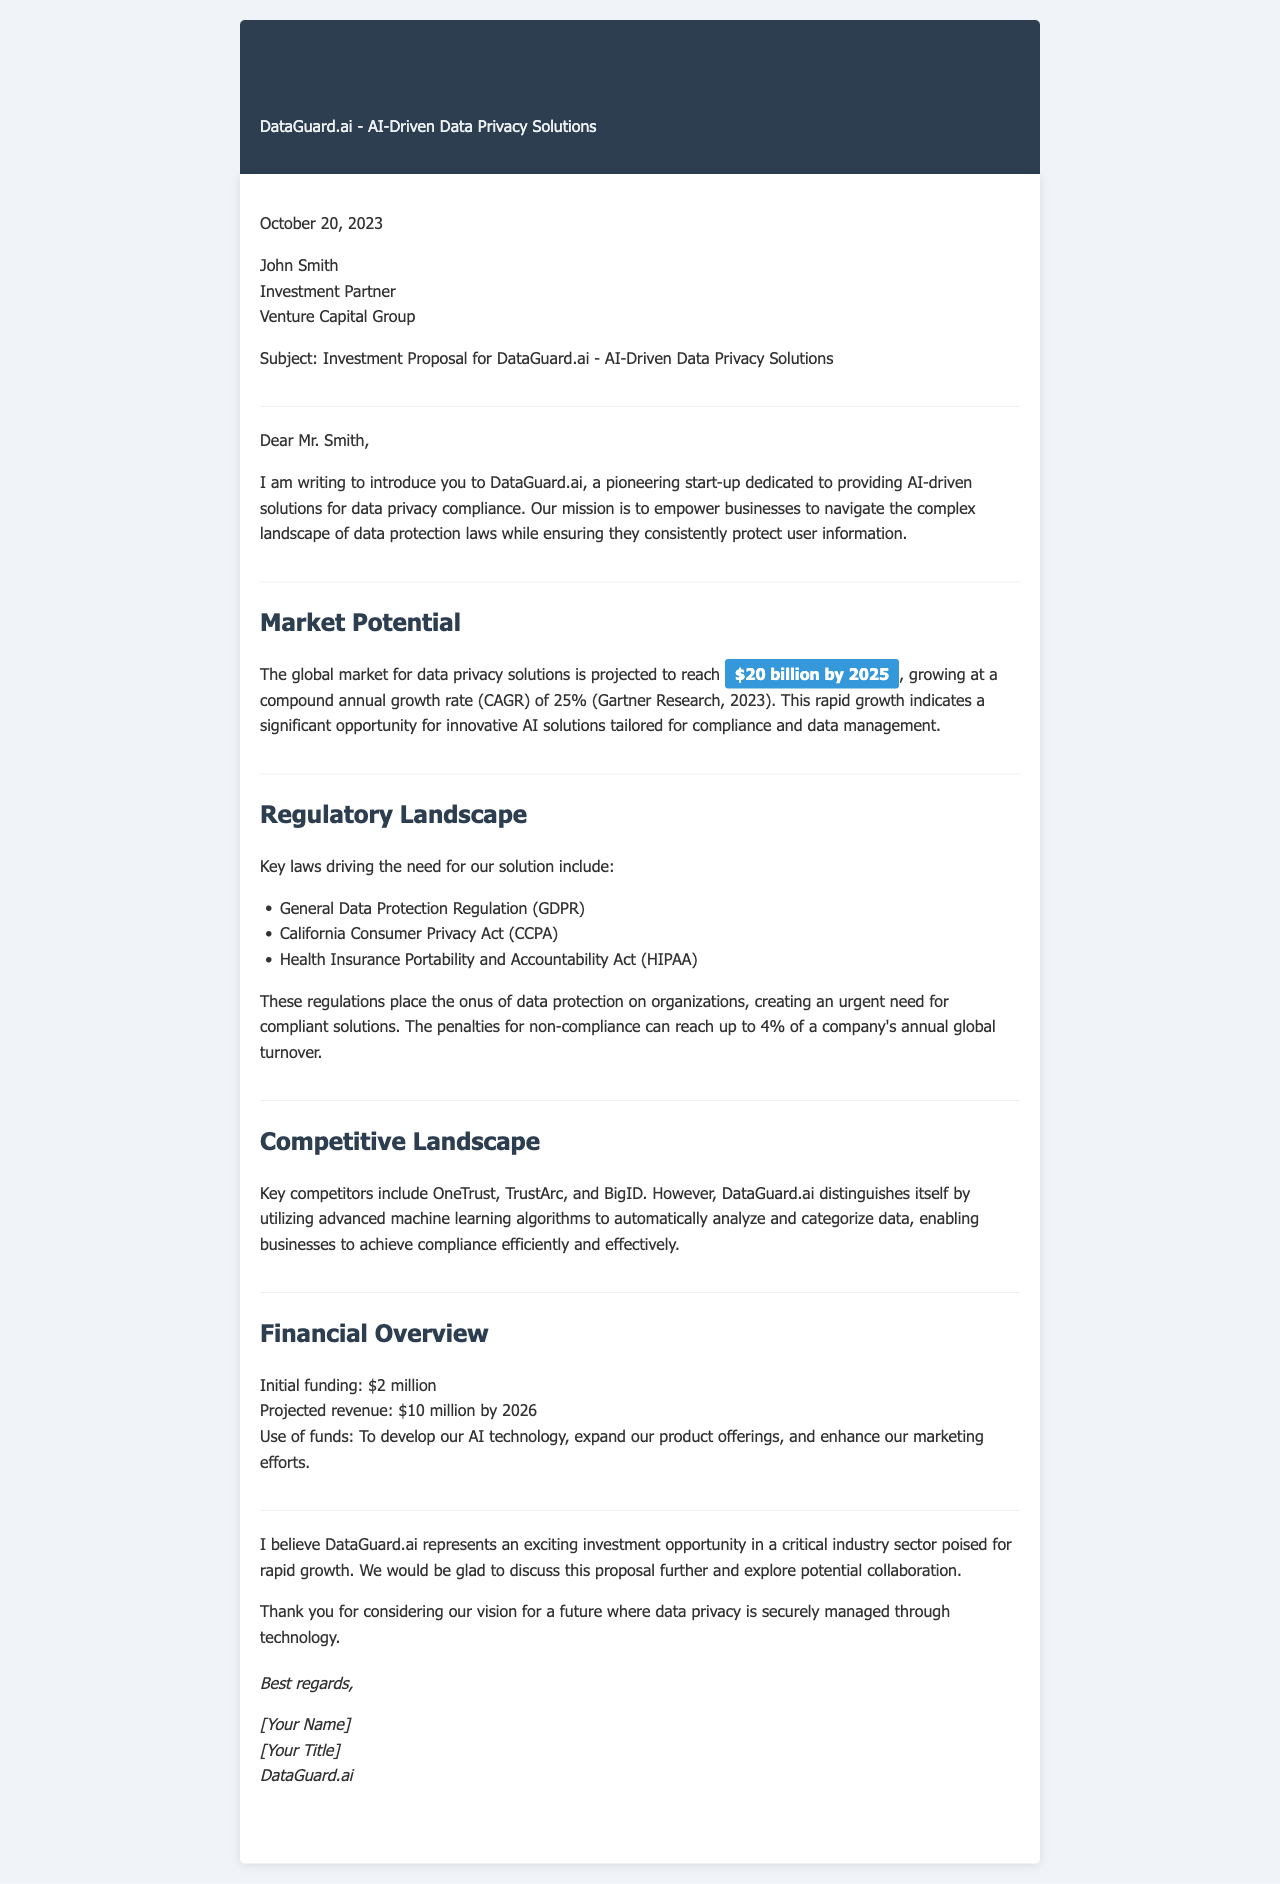What is the projected market size for data privacy solutions by 2025? The projected market size is detailed in the proposal, where it states the global market for data privacy solutions is expected to reach $20 billion by 2025.
Answer: $20 billion What is the compound annual growth rate (CAGR) mentioned for the market growth? The document specifies a CAGR of 25% for the data privacy solutions market based on Gartner Research.
Answer: 25% Which regulation is first listed in the regulatory landscape? The first regulation mentioned that drives the need for the solution is the General Data Protection Regulation (GDPR).
Answer: General Data Protection Regulation (GDPR) What is the initial funding amount mentioned in the financial overview? The financial overview states that the initial funding for DataGuard.ai is $2 million.
Answer: $2 million What distinguishes DataGuard.ai from its competitors? The document describes that DataGuard.ai distinguishes itself by utilizing advanced machine learning algorithms to automatically analyze and categorize data.
Answer: Advanced machine learning algorithms What is the name of the recipient of the investment proposal letter? The recipient of the letter, mentioned in the salutation, is John Smith.
Answer: John Smith What is the projected revenue by 2026 according to the financial overview? The projected revenue mentioned in the document is $10 million by 2026.
Answer: $10 million What is the subject of the investment proposal letter? The subject line states that the proposal is for DataGuard.ai - AI-Driven Data Privacy Solutions.
Answer: Investment Proposal for DataGuard.ai - AI-Driven Data Privacy Solutions What is the date on the investment proposal letter? The document provides the date at the beginning, which is October 20, 2023.
Answer: October 20, 2023 What does the letter conclude with? The conclusion expresses a willingness to discuss the proposal further and explore potential collaboration, indicating the company's openness to dialogue.
Answer: Thank you for considering our vision for a future where data privacy is securely managed through technology 